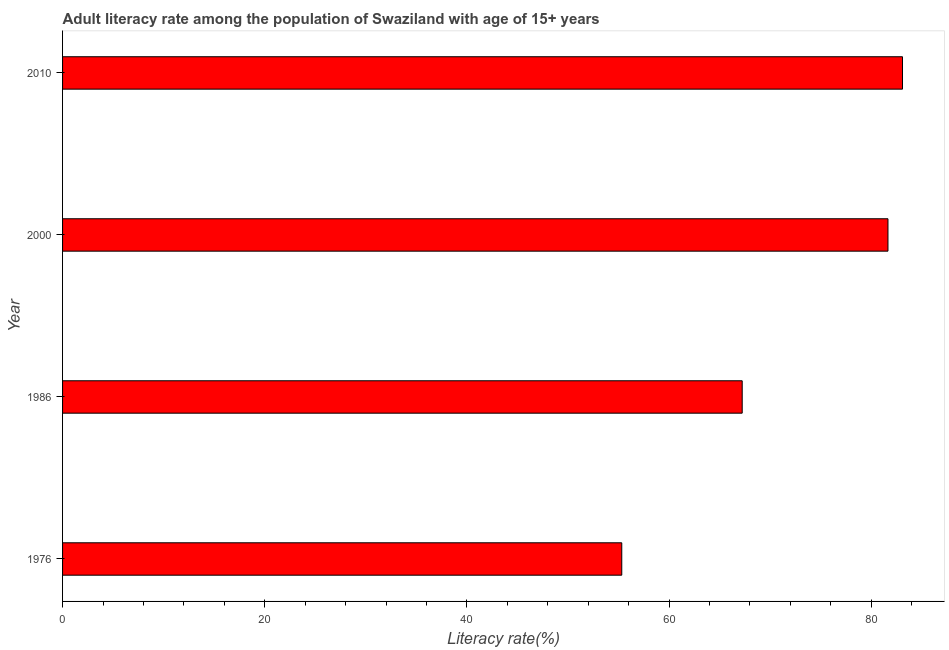Does the graph contain any zero values?
Ensure brevity in your answer.  No. Does the graph contain grids?
Make the answer very short. No. What is the title of the graph?
Ensure brevity in your answer.  Adult literacy rate among the population of Swaziland with age of 15+ years. What is the label or title of the X-axis?
Provide a short and direct response. Literacy rate(%). What is the adult literacy rate in 1986?
Your answer should be compact. 67.24. Across all years, what is the maximum adult literacy rate?
Your answer should be very brief. 83.1. Across all years, what is the minimum adult literacy rate?
Your answer should be very brief. 55.33. In which year was the adult literacy rate minimum?
Your answer should be compact. 1976. What is the sum of the adult literacy rate?
Give a very brief answer. 287.32. What is the difference between the adult literacy rate in 1986 and 2000?
Keep it short and to the point. -14.42. What is the average adult literacy rate per year?
Provide a short and direct response. 71.83. What is the median adult literacy rate?
Offer a very short reply. 74.45. Do a majority of the years between 1986 and 2000 (inclusive) have adult literacy rate greater than 76 %?
Provide a short and direct response. No. What is the ratio of the adult literacy rate in 1986 to that in 2010?
Offer a terse response. 0.81. What is the difference between the highest and the second highest adult literacy rate?
Your answer should be compact. 1.44. What is the difference between the highest and the lowest adult literacy rate?
Provide a short and direct response. 27.77. In how many years, is the adult literacy rate greater than the average adult literacy rate taken over all years?
Keep it short and to the point. 2. How many bars are there?
Make the answer very short. 4. Are all the bars in the graph horizontal?
Your response must be concise. Yes. How many years are there in the graph?
Your response must be concise. 4. What is the Literacy rate(%) in 1976?
Ensure brevity in your answer.  55.33. What is the Literacy rate(%) in 1986?
Offer a terse response. 67.24. What is the Literacy rate(%) of 2000?
Keep it short and to the point. 81.66. What is the Literacy rate(%) of 2010?
Ensure brevity in your answer.  83.1. What is the difference between the Literacy rate(%) in 1976 and 1986?
Your answer should be very brief. -11.91. What is the difference between the Literacy rate(%) in 1976 and 2000?
Ensure brevity in your answer.  -26.34. What is the difference between the Literacy rate(%) in 1976 and 2010?
Give a very brief answer. -27.77. What is the difference between the Literacy rate(%) in 1986 and 2000?
Your answer should be very brief. -14.42. What is the difference between the Literacy rate(%) in 1986 and 2010?
Your answer should be compact. -15.86. What is the difference between the Literacy rate(%) in 2000 and 2010?
Your answer should be very brief. -1.44. What is the ratio of the Literacy rate(%) in 1976 to that in 1986?
Give a very brief answer. 0.82. What is the ratio of the Literacy rate(%) in 1976 to that in 2000?
Your response must be concise. 0.68. What is the ratio of the Literacy rate(%) in 1976 to that in 2010?
Your response must be concise. 0.67. What is the ratio of the Literacy rate(%) in 1986 to that in 2000?
Provide a succinct answer. 0.82. What is the ratio of the Literacy rate(%) in 1986 to that in 2010?
Provide a short and direct response. 0.81. What is the ratio of the Literacy rate(%) in 2000 to that in 2010?
Give a very brief answer. 0.98. 